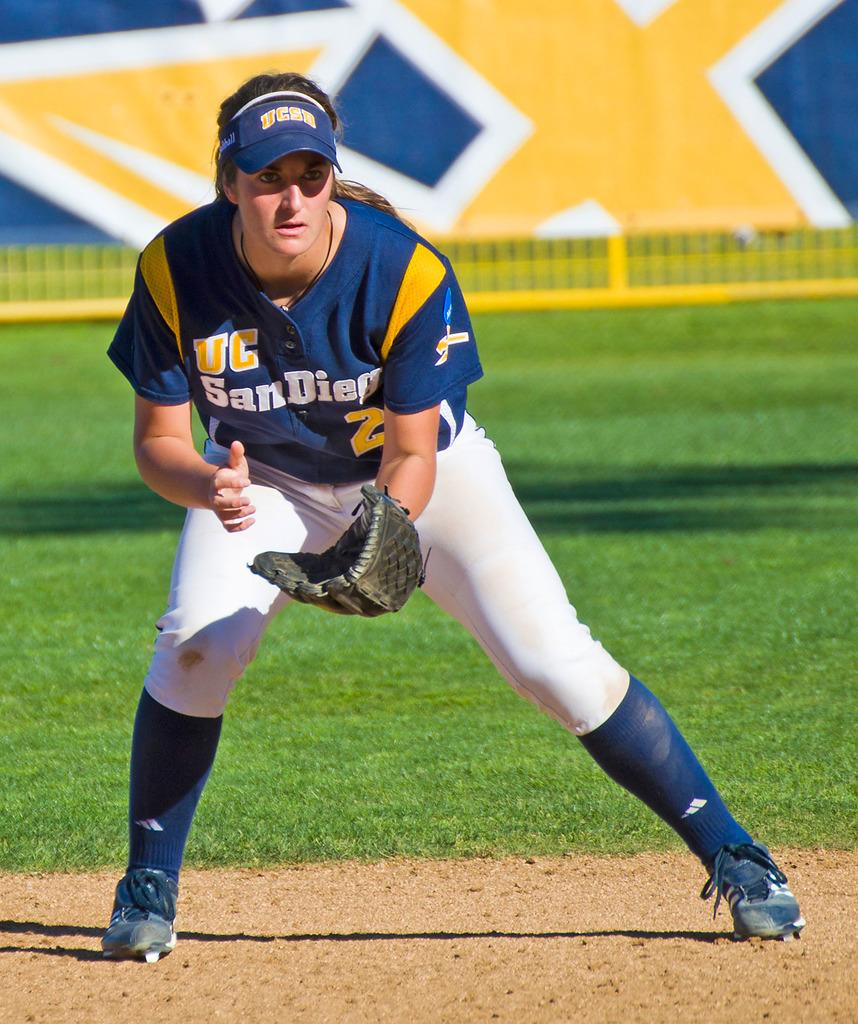Provide a one-sentence caption for the provided image. The UC San Diego player is ready to catch the ball. 